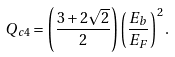<formula> <loc_0><loc_0><loc_500><loc_500>Q _ { c 4 } = \left ( \frac { 3 + 2 \sqrt { 2 } } { 2 } \right ) \left ( \frac { E _ { b } } { E _ { F } } \right ) ^ { 2 } .</formula> 